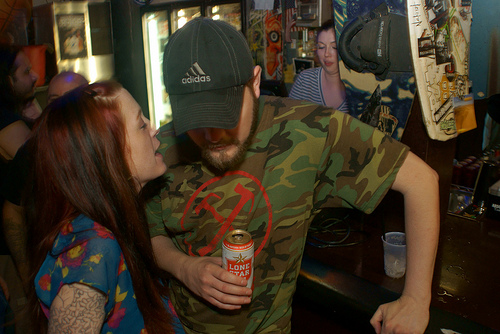<image>
Is there a can to the right of the woman? Yes. From this viewpoint, the can is positioned to the right side relative to the woman. 